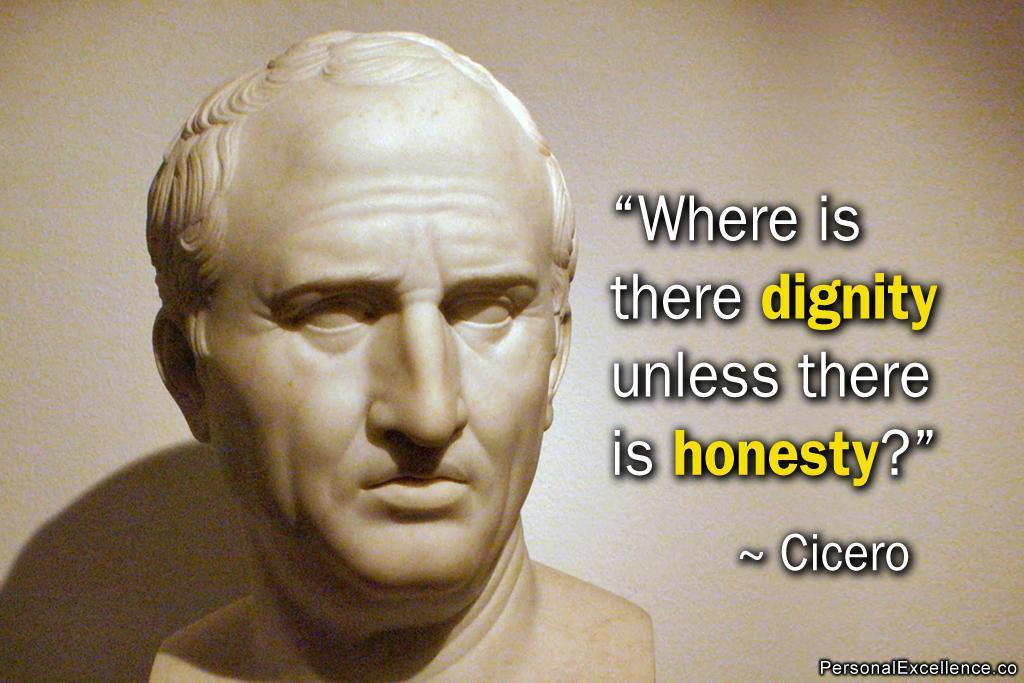What is featured on the poster in the image? There is a poster in the image, and it contains a sculpture. What else can be seen on the poster besides the sculpture? There is text present on the poster. How does the spoon contribute to the income of the sculpture in the image? There is no spoon present in the image, and the sculpture's income is not mentioned or depicted. 